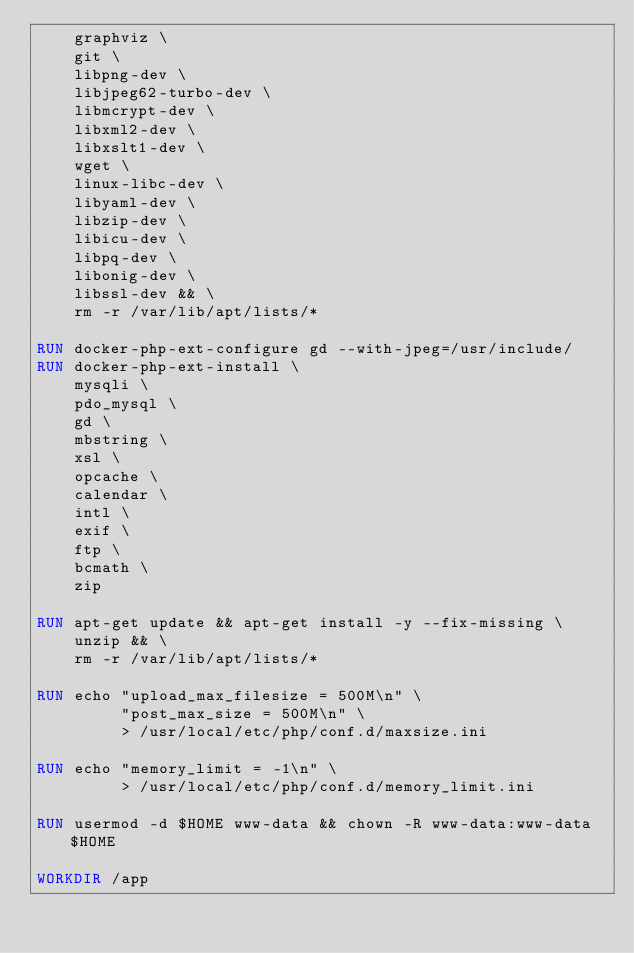Convert code to text. <code><loc_0><loc_0><loc_500><loc_500><_Dockerfile_>    graphviz \
    git \
    libpng-dev \
    libjpeg62-turbo-dev \
    libmcrypt-dev \
    libxml2-dev \
    libxslt1-dev \
    wget \
    linux-libc-dev \
    libyaml-dev \
    libzip-dev \
    libicu-dev \
    libpq-dev \
    libonig-dev \
    libssl-dev && \
    rm -r /var/lib/apt/lists/*
    
RUN docker-php-ext-configure gd --with-jpeg=/usr/include/
RUN docker-php-ext-install \
    mysqli \
    pdo_mysql \
    gd \
    mbstring \
    xsl \
    opcache \
    calendar \
    intl \
    exif \
    ftp \
    bcmath \
    zip

RUN apt-get update && apt-get install -y --fix-missing \
    unzip && \
    rm -r /var/lib/apt/lists/*

RUN echo "upload_max_filesize = 500M\n" \
         "post_max_size = 500M\n" \
         > /usr/local/etc/php/conf.d/maxsize.ini

RUN echo "memory_limit = -1\n" \
         > /usr/local/etc/php/conf.d/memory_limit.ini

RUN usermod -d $HOME www-data && chown -R www-data:www-data $HOME

WORKDIR /app</code> 